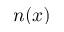Convert formula to latex. <formula><loc_0><loc_0><loc_500><loc_500>n ( x )</formula> 